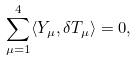Convert formula to latex. <formula><loc_0><loc_0><loc_500><loc_500>\sum _ { \mu = 1 } ^ { 4 } \langle Y _ { \mu } , \delta T _ { \mu } \rangle = 0 ,</formula> 